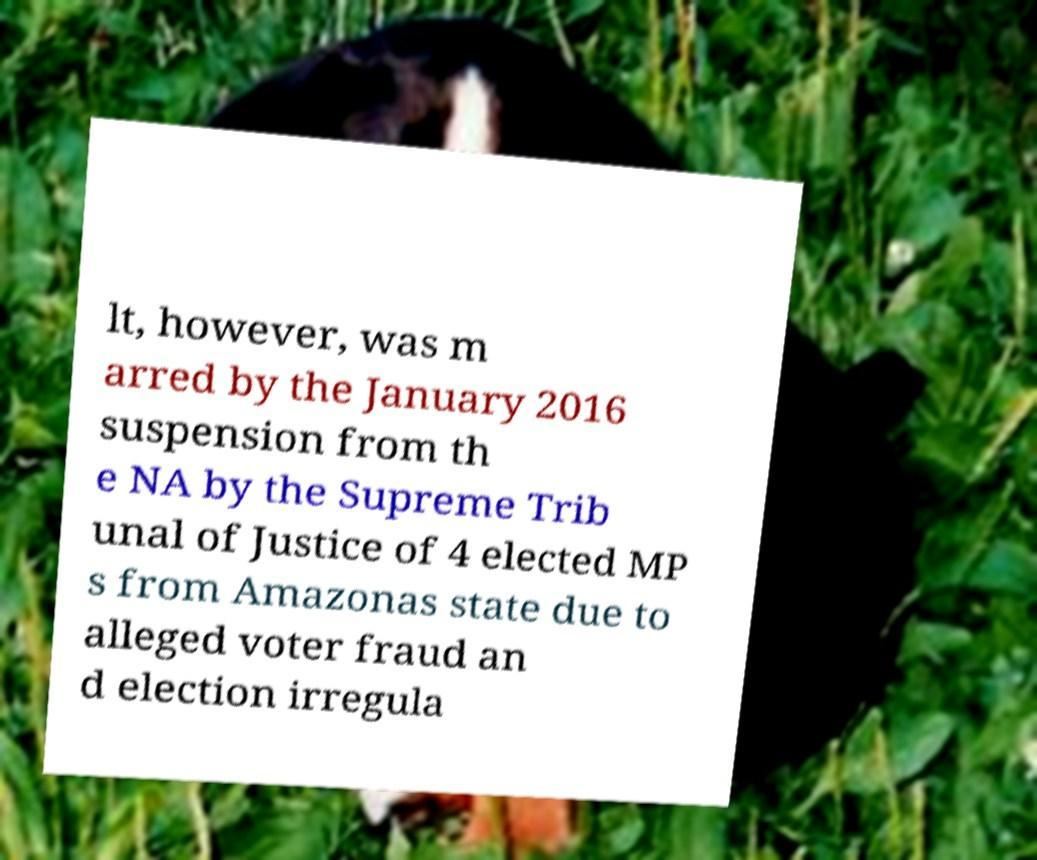Please read and relay the text visible in this image. What does it say? lt, however, was m arred by the January 2016 suspension from th e NA by the Supreme Trib unal of Justice of 4 elected MP s from Amazonas state due to alleged voter fraud an d election irregula 